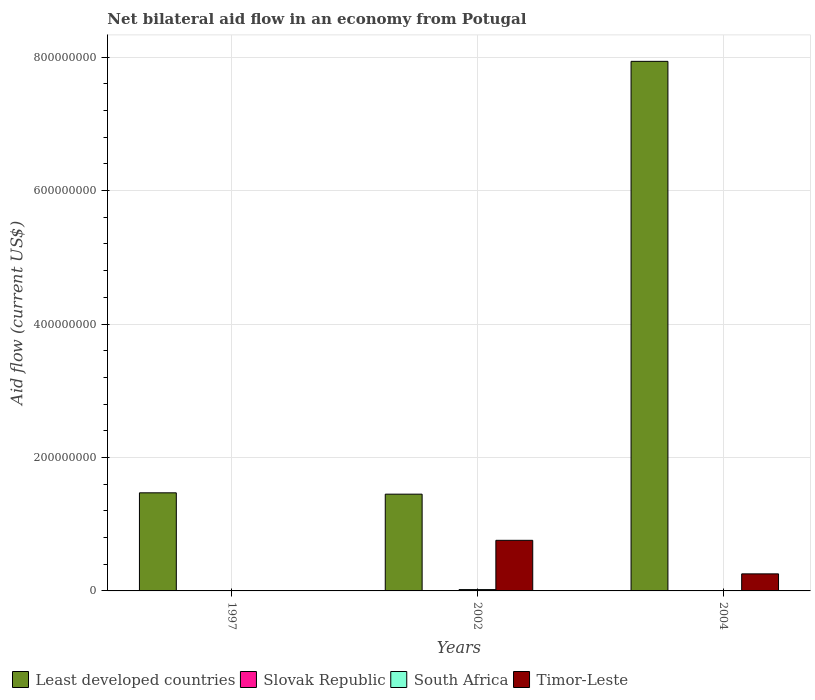How many groups of bars are there?
Your response must be concise. 3. Are the number of bars per tick equal to the number of legend labels?
Your answer should be very brief. Yes. Are the number of bars on each tick of the X-axis equal?
Offer a very short reply. Yes. How many bars are there on the 1st tick from the left?
Give a very brief answer. 4. What is the net bilateral aid flow in South Africa in 2002?
Provide a short and direct response. 2.01e+06. Across all years, what is the maximum net bilateral aid flow in Timor-Leste?
Ensure brevity in your answer.  7.58e+07. Across all years, what is the minimum net bilateral aid flow in Slovak Republic?
Your answer should be very brief. 10000. In which year was the net bilateral aid flow in Slovak Republic minimum?
Offer a terse response. 1997. What is the difference between the net bilateral aid flow in South Africa in 2002 and that in 2004?
Give a very brief answer. 1.61e+06. What is the difference between the net bilateral aid flow in Slovak Republic in 1997 and the net bilateral aid flow in Least developed countries in 2004?
Offer a terse response. -7.94e+08. What is the average net bilateral aid flow in South Africa per year?
Offer a terse response. 8.17e+05. In the year 2002, what is the difference between the net bilateral aid flow in South Africa and net bilateral aid flow in Least developed countries?
Offer a terse response. -1.43e+08. In how many years, is the net bilateral aid flow in Slovak Republic greater than 120000000 US$?
Provide a short and direct response. 0. What is the ratio of the net bilateral aid flow in Slovak Republic in 1997 to that in 2004?
Ensure brevity in your answer.  1. Is the net bilateral aid flow in Slovak Republic in 1997 less than that in 2002?
Provide a short and direct response. No. What is the difference between the highest and the second highest net bilateral aid flow in Timor-Leste?
Offer a terse response. 5.03e+07. What is the difference between the highest and the lowest net bilateral aid flow in Slovak Republic?
Give a very brief answer. 0. In how many years, is the net bilateral aid flow in Slovak Republic greater than the average net bilateral aid flow in Slovak Republic taken over all years?
Give a very brief answer. 0. Is the sum of the net bilateral aid flow in Least developed countries in 2002 and 2004 greater than the maximum net bilateral aid flow in Slovak Republic across all years?
Your answer should be compact. Yes. Is it the case that in every year, the sum of the net bilateral aid flow in Least developed countries and net bilateral aid flow in Timor-Leste is greater than the sum of net bilateral aid flow in Slovak Republic and net bilateral aid flow in South Africa?
Make the answer very short. No. What does the 4th bar from the left in 2002 represents?
Give a very brief answer. Timor-Leste. What does the 1st bar from the right in 1997 represents?
Keep it short and to the point. Timor-Leste. Is it the case that in every year, the sum of the net bilateral aid flow in Slovak Republic and net bilateral aid flow in Timor-Leste is greater than the net bilateral aid flow in South Africa?
Your answer should be compact. Yes. How many bars are there?
Provide a succinct answer. 12. Are all the bars in the graph horizontal?
Offer a very short reply. No. Are the values on the major ticks of Y-axis written in scientific E-notation?
Your answer should be compact. No. Does the graph contain any zero values?
Provide a short and direct response. No. How many legend labels are there?
Your response must be concise. 4. How are the legend labels stacked?
Make the answer very short. Horizontal. What is the title of the graph?
Ensure brevity in your answer.  Net bilateral aid flow in an economy from Potugal. What is the label or title of the Y-axis?
Your answer should be compact. Aid flow (current US$). What is the Aid flow (current US$) of Least developed countries in 1997?
Provide a succinct answer. 1.47e+08. What is the Aid flow (current US$) of South Africa in 1997?
Make the answer very short. 4.00e+04. What is the Aid flow (current US$) in Least developed countries in 2002?
Provide a succinct answer. 1.45e+08. What is the Aid flow (current US$) of Slovak Republic in 2002?
Your response must be concise. 10000. What is the Aid flow (current US$) of South Africa in 2002?
Offer a terse response. 2.01e+06. What is the Aid flow (current US$) of Timor-Leste in 2002?
Give a very brief answer. 7.58e+07. What is the Aid flow (current US$) of Least developed countries in 2004?
Your response must be concise. 7.94e+08. What is the Aid flow (current US$) in Slovak Republic in 2004?
Make the answer very short. 10000. What is the Aid flow (current US$) of Timor-Leste in 2004?
Your answer should be very brief. 2.56e+07. Across all years, what is the maximum Aid flow (current US$) in Least developed countries?
Offer a terse response. 7.94e+08. Across all years, what is the maximum Aid flow (current US$) in South Africa?
Your answer should be compact. 2.01e+06. Across all years, what is the maximum Aid flow (current US$) in Timor-Leste?
Your answer should be compact. 7.58e+07. Across all years, what is the minimum Aid flow (current US$) in Least developed countries?
Your response must be concise. 1.45e+08. What is the total Aid flow (current US$) in Least developed countries in the graph?
Make the answer very short. 1.09e+09. What is the total Aid flow (current US$) in South Africa in the graph?
Ensure brevity in your answer.  2.45e+06. What is the total Aid flow (current US$) of Timor-Leste in the graph?
Ensure brevity in your answer.  1.02e+08. What is the difference between the Aid flow (current US$) in Least developed countries in 1997 and that in 2002?
Give a very brief answer. 2.02e+06. What is the difference between the Aid flow (current US$) of Slovak Republic in 1997 and that in 2002?
Give a very brief answer. 0. What is the difference between the Aid flow (current US$) of South Africa in 1997 and that in 2002?
Give a very brief answer. -1.97e+06. What is the difference between the Aid flow (current US$) of Timor-Leste in 1997 and that in 2002?
Your answer should be compact. -7.55e+07. What is the difference between the Aid flow (current US$) of Least developed countries in 1997 and that in 2004?
Keep it short and to the point. -6.47e+08. What is the difference between the Aid flow (current US$) in Slovak Republic in 1997 and that in 2004?
Your response must be concise. 0. What is the difference between the Aid flow (current US$) in South Africa in 1997 and that in 2004?
Provide a succinct answer. -3.60e+05. What is the difference between the Aid flow (current US$) of Timor-Leste in 1997 and that in 2004?
Offer a very short reply. -2.52e+07. What is the difference between the Aid flow (current US$) in Least developed countries in 2002 and that in 2004?
Make the answer very short. -6.49e+08. What is the difference between the Aid flow (current US$) of Slovak Republic in 2002 and that in 2004?
Your answer should be compact. 0. What is the difference between the Aid flow (current US$) of South Africa in 2002 and that in 2004?
Keep it short and to the point. 1.61e+06. What is the difference between the Aid flow (current US$) of Timor-Leste in 2002 and that in 2004?
Your answer should be compact. 5.03e+07. What is the difference between the Aid flow (current US$) in Least developed countries in 1997 and the Aid flow (current US$) in Slovak Republic in 2002?
Provide a short and direct response. 1.47e+08. What is the difference between the Aid flow (current US$) in Least developed countries in 1997 and the Aid flow (current US$) in South Africa in 2002?
Ensure brevity in your answer.  1.45e+08. What is the difference between the Aid flow (current US$) in Least developed countries in 1997 and the Aid flow (current US$) in Timor-Leste in 2002?
Your response must be concise. 7.12e+07. What is the difference between the Aid flow (current US$) of Slovak Republic in 1997 and the Aid flow (current US$) of Timor-Leste in 2002?
Offer a very short reply. -7.58e+07. What is the difference between the Aid flow (current US$) of South Africa in 1997 and the Aid flow (current US$) of Timor-Leste in 2002?
Offer a very short reply. -7.58e+07. What is the difference between the Aid flow (current US$) of Least developed countries in 1997 and the Aid flow (current US$) of Slovak Republic in 2004?
Ensure brevity in your answer.  1.47e+08. What is the difference between the Aid flow (current US$) in Least developed countries in 1997 and the Aid flow (current US$) in South Africa in 2004?
Keep it short and to the point. 1.47e+08. What is the difference between the Aid flow (current US$) of Least developed countries in 1997 and the Aid flow (current US$) of Timor-Leste in 2004?
Your response must be concise. 1.21e+08. What is the difference between the Aid flow (current US$) of Slovak Republic in 1997 and the Aid flow (current US$) of South Africa in 2004?
Offer a terse response. -3.90e+05. What is the difference between the Aid flow (current US$) of Slovak Republic in 1997 and the Aid flow (current US$) of Timor-Leste in 2004?
Provide a short and direct response. -2.55e+07. What is the difference between the Aid flow (current US$) in South Africa in 1997 and the Aid flow (current US$) in Timor-Leste in 2004?
Your answer should be compact. -2.55e+07. What is the difference between the Aid flow (current US$) in Least developed countries in 2002 and the Aid flow (current US$) in Slovak Republic in 2004?
Your answer should be very brief. 1.45e+08. What is the difference between the Aid flow (current US$) in Least developed countries in 2002 and the Aid flow (current US$) in South Africa in 2004?
Offer a very short reply. 1.45e+08. What is the difference between the Aid flow (current US$) in Least developed countries in 2002 and the Aid flow (current US$) in Timor-Leste in 2004?
Make the answer very short. 1.19e+08. What is the difference between the Aid flow (current US$) of Slovak Republic in 2002 and the Aid flow (current US$) of South Africa in 2004?
Your response must be concise. -3.90e+05. What is the difference between the Aid flow (current US$) of Slovak Republic in 2002 and the Aid flow (current US$) of Timor-Leste in 2004?
Provide a short and direct response. -2.55e+07. What is the difference between the Aid flow (current US$) in South Africa in 2002 and the Aid flow (current US$) in Timor-Leste in 2004?
Provide a succinct answer. -2.35e+07. What is the average Aid flow (current US$) of Least developed countries per year?
Make the answer very short. 3.62e+08. What is the average Aid flow (current US$) in Slovak Republic per year?
Provide a succinct answer. 10000. What is the average Aid flow (current US$) in South Africa per year?
Offer a very short reply. 8.17e+05. What is the average Aid flow (current US$) of Timor-Leste per year?
Make the answer very short. 3.39e+07. In the year 1997, what is the difference between the Aid flow (current US$) in Least developed countries and Aid flow (current US$) in Slovak Republic?
Provide a short and direct response. 1.47e+08. In the year 1997, what is the difference between the Aid flow (current US$) in Least developed countries and Aid flow (current US$) in South Africa?
Offer a very short reply. 1.47e+08. In the year 1997, what is the difference between the Aid flow (current US$) of Least developed countries and Aid flow (current US$) of Timor-Leste?
Your answer should be very brief. 1.47e+08. In the year 1997, what is the difference between the Aid flow (current US$) in Slovak Republic and Aid flow (current US$) in Timor-Leste?
Offer a terse response. -3.00e+05. In the year 2002, what is the difference between the Aid flow (current US$) of Least developed countries and Aid flow (current US$) of Slovak Republic?
Give a very brief answer. 1.45e+08. In the year 2002, what is the difference between the Aid flow (current US$) in Least developed countries and Aid flow (current US$) in South Africa?
Keep it short and to the point. 1.43e+08. In the year 2002, what is the difference between the Aid flow (current US$) of Least developed countries and Aid flow (current US$) of Timor-Leste?
Your response must be concise. 6.92e+07. In the year 2002, what is the difference between the Aid flow (current US$) in Slovak Republic and Aid flow (current US$) in South Africa?
Provide a short and direct response. -2.00e+06. In the year 2002, what is the difference between the Aid flow (current US$) of Slovak Republic and Aid flow (current US$) of Timor-Leste?
Give a very brief answer. -7.58e+07. In the year 2002, what is the difference between the Aid flow (current US$) in South Africa and Aid flow (current US$) in Timor-Leste?
Offer a very short reply. -7.38e+07. In the year 2004, what is the difference between the Aid flow (current US$) in Least developed countries and Aid flow (current US$) in Slovak Republic?
Provide a succinct answer. 7.94e+08. In the year 2004, what is the difference between the Aid flow (current US$) of Least developed countries and Aid flow (current US$) of South Africa?
Make the answer very short. 7.93e+08. In the year 2004, what is the difference between the Aid flow (current US$) in Least developed countries and Aid flow (current US$) in Timor-Leste?
Keep it short and to the point. 7.68e+08. In the year 2004, what is the difference between the Aid flow (current US$) in Slovak Republic and Aid flow (current US$) in South Africa?
Give a very brief answer. -3.90e+05. In the year 2004, what is the difference between the Aid flow (current US$) of Slovak Republic and Aid flow (current US$) of Timor-Leste?
Your answer should be very brief. -2.55e+07. In the year 2004, what is the difference between the Aid flow (current US$) of South Africa and Aid flow (current US$) of Timor-Leste?
Your answer should be compact. -2.52e+07. What is the ratio of the Aid flow (current US$) of Least developed countries in 1997 to that in 2002?
Provide a short and direct response. 1.01. What is the ratio of the Aid flow (current US$) in Slovak Republic in 1997 to that in 2002?
Your answer should be very brief. 1. What is the ratio of the Aid flow (current US$) in South Africa in 1997 to that in 2002?
Make the answer very short. 0.02. What is the ratio of the Aid flow (current US$) in Timor-Leste in 1997 to that in 2002?
Offer a terse response. 0. What is the ratio of the Aid flow (current US$) in Least developed countries in 1997 to that in 2004?
Ensure brevity in your answer.  0.19. What is the ratio of the Aid flow (current US$) in South Africa in 1997 to that in 2004?
Your answer should be very brief. 0.1. What is the ratio of the Aid flow (current US$) in Timor-Leste in 1997 to that in 2004?
Provide a succinct answer. 0.01. What is the ratio of the Aid flow (current US$) of Least developed countries in 2002 to that in 2004?
Make the answer very short. 0.18. What is the ratio of the Aid flow (current US$) of South Africa in 2002 to that in 2004?
Provide a short and direct response. 5.03. What is the ratio of the Aid flow (current US$) in Timor-Leste in 2002 to that in 2004?
Offer a terse response. 2.97. What is the difference between the highest and the second highest Aid flow (current US$) of Least developed countries?
Your answer should be very brief. 6.47e+08. What is the difference between the highest and the second highest Aid flow (current US$) in Slovak Republic?
Give a very brief answer. 0. What is the difference between the highest and the second highest Aid flow (current US$) of South Africa?
Make the answer very short. 1.61e+06. What is the difference between the highest and the second highest Aid flow (current US$) in Timor-Leste?
Offer a very short reply. 5.03e+07. What is the difference between the highest and the lowest Aid flow (current US$) in Least developed countries?
Offer a very short reply. 6.49e+08. What is the difference between the highest and the lowest Aid flow (current US$) in South Africa?
Offer a terse response. 1.97e+06. What is the difference between the highest and the lowest Aid flow (current US$) of Timor-Leste?
Give a very brief answer. 7.55e+07. 